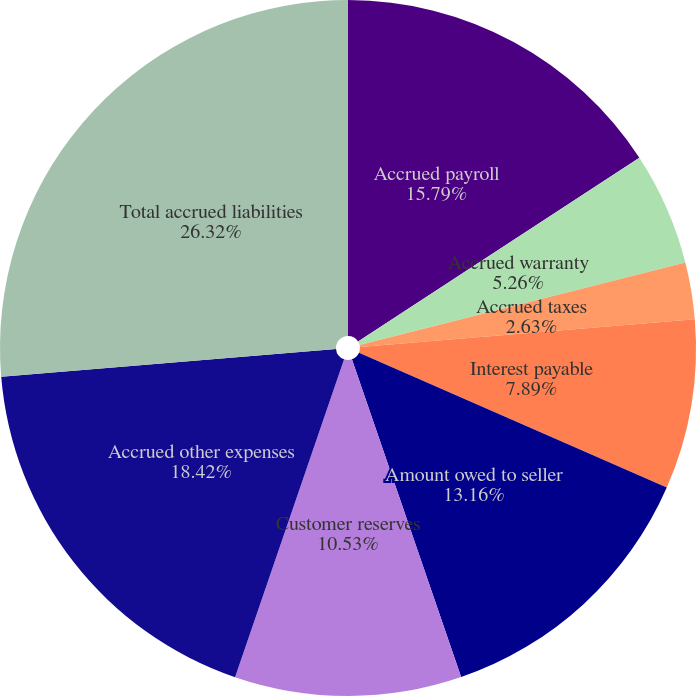<chart> <loc_0><loc_0><loc_500><loc_500><pie_chart><fcel>Accrued payroll<fcel>Accrued warranty<fcel>Accrued taxes<fcel>Accrued forward contracts<fcel>Interest payable<fcel>Amount owed to seller<fcel>Customer reserves<fcel>Accrued other expenses<fcel>Total accrued liabilities<nl><fcel>15.79%<fcel>5.26%<fcel>2.63%<fcel>0.0%<fcel>7.89%<fcel>13.16%<fcel>10.53%<fcel>18.42%<fcel>26.32%<nl></chart> 